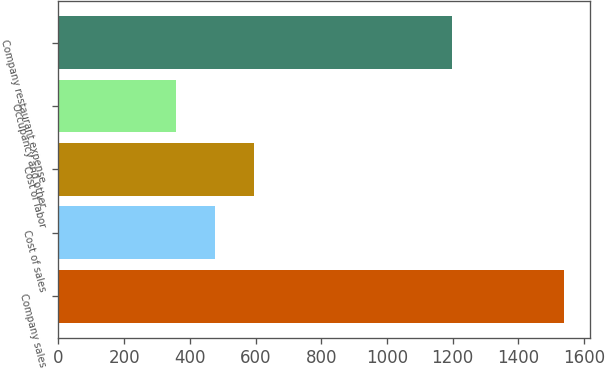Convert chart to OTSL. <chart><loc_0><loc_0><loc_500><loc_500><bar_chart><fcel>Company sales<fcel>Cost of sales<fcel>Cost of labor<fcel>Occupancy and other<fcel>Company restaurant expense<nl><fcel>1540<fcel>476.2<fcel>594.4<fcel>358<fcel>1198<nl></chart> 